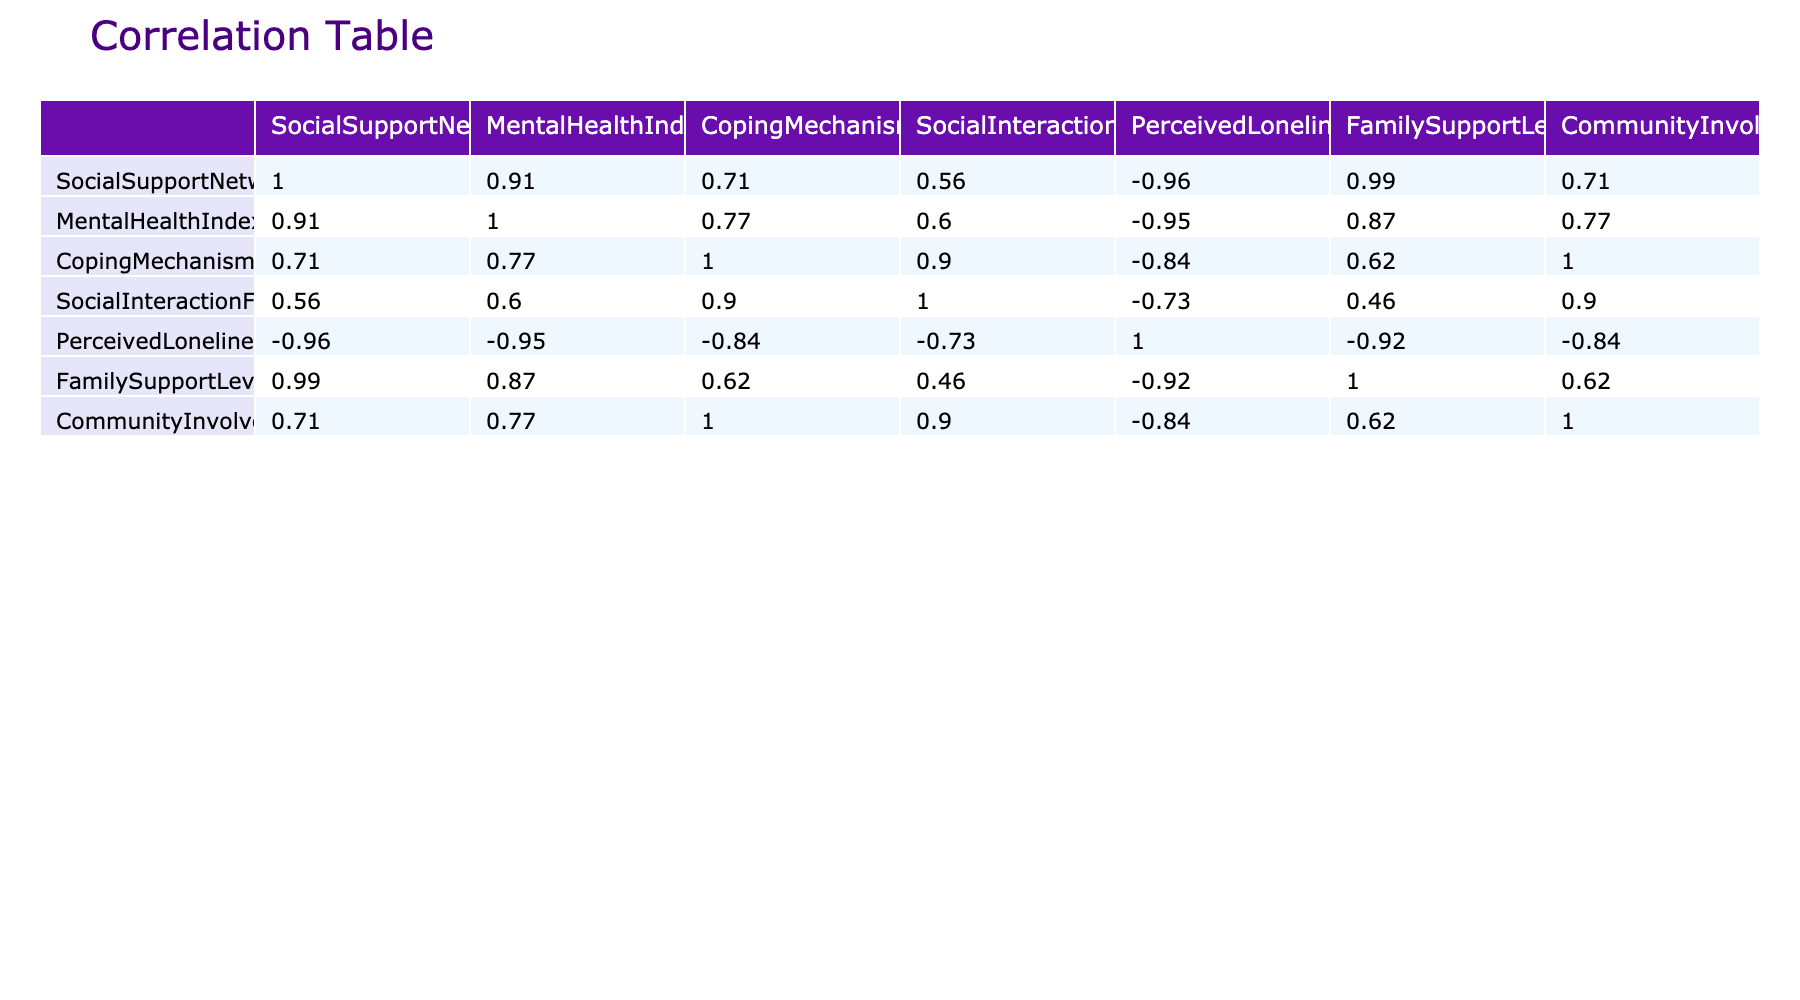What is the correlation between Social Support Network Effectiveness and Mental Health Index? The value for the correlation between Social Support Network Effectiveness and Mental Health Index is 0.77, which indicates a strong positive relationship.
Answer: 0.77 What value does the Family Support Level have in relation to Coping Mechanisms Usage? The correlation value between Family Support Level and Coping Mechanisms Usage is 0.47, showing a moderate positive relationship.
Answer: 0.47 Is there a negative correlation between Perceived Loneliness and Social Support Network Effectiveness? The correlation value for Perceived Loneliness and Social Support Network Effectiveness is -0.58, indicating a notable negative relationship.
Answer: Yes What are the average values for Mental Health Index and Community Involvement? The average for the Mental Health Index is calculated as (7 + 5 + 8 + 6 + 4 + 7 + 5 + 9) = 51, then divided by the 8 data points gives 51/8 = 6.375. The average for Community Involvement is (4 + 3 + 5 + 2 + 3 + 4 + 4 + 6) = 31, then 31/8 = 3.875.
Answer: Mental Health Index: 6.375, Community Involvement: 3.875 What is the difference between the maximum and minimum values of Social Interaction Frequency? The maximum value for Social Interaction Frequency is 9 and the minimum value is 3. The difference is calculated as 9 - 3 = 6.
Answer: 6 Is the correlation between Community Involvement and Mental Health Index greater than 0.5? The correlation value between Community Involvement and Mental Health Index is 0.54, which is greater than 0.5.
Answer: Yes What is the correlation between Coping Mechanisms Usage and Perceived Loneliness, and what does it indicate? The correlation between Coping Mechanisms Usage and Perceived Loneliness is -0.43. This indicates a moderate negative correlation, meaning as coping mechanisms increase, perceived loneliness tends to decrease.
Answer: -0.43 Which variable has the highest correlation with Mental Health Index? The variable with the highest correlation is Social Support Network Effectiveness, with a correlation value of 0.77.
Answer: Social Support Network Effectiveness What are the correlation values for Social Support Network Effectiveness with Perceived Loneliness and Community Involvement? The correlation of Social Support Network Effectiveness with Perceived Loneliness is -0.58 and with Community Involvement is 0.47.
Answer: Perceived Loneliness: -0.58, Community Involvement: 0.47 